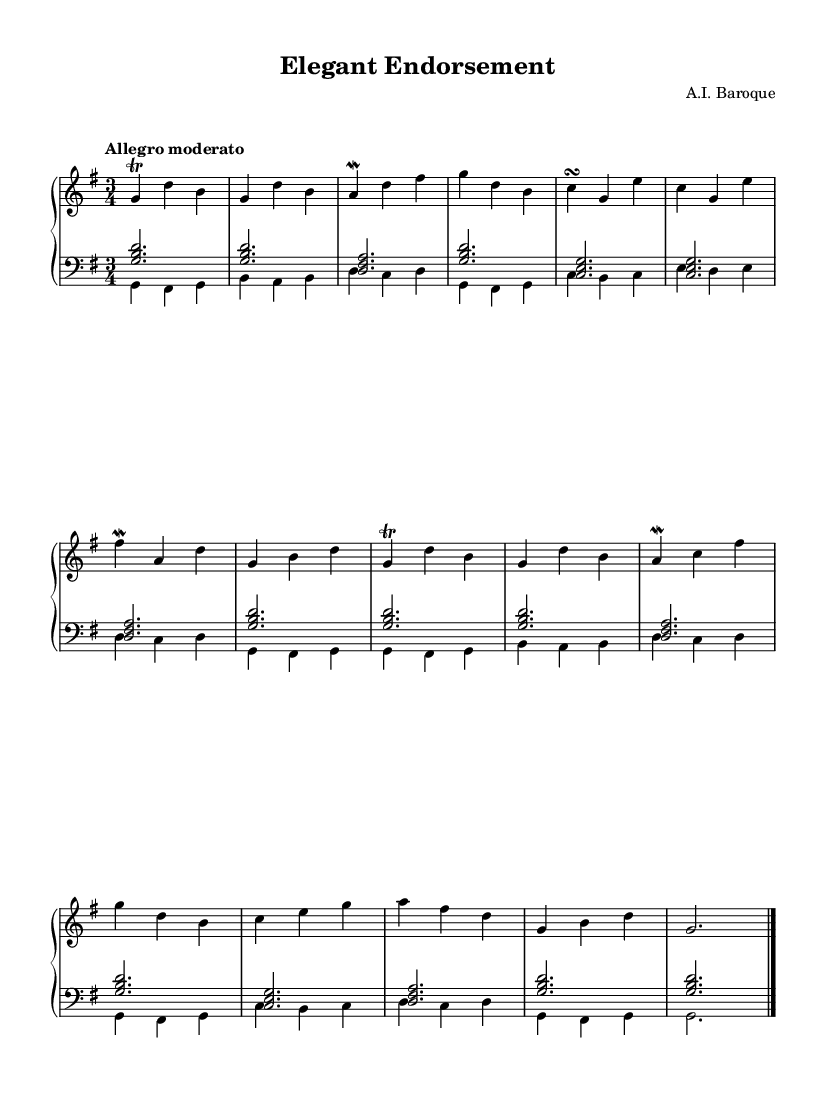What is the key signature of this piece? The key signature is G major, which has one sharp (F#). This can be determined by looking at the key signature indicated at the beginning of the piece.
Answer: G major What is the time signature of this music? The time signature is 3/4, which can be found at the beginning of the sheet music next to the key signature. This indicates that there are three beats in each measure and the quarter note gets one beat.
Answer: 3/4 What is the tempo marking of this piece? The tempo marking indicates "Allegro moderato." This can be found at the start of the piece and denotes a moderately fast tempo.
Answer: Allegro moderato How many measures are in the piece? To find the total number of measures, one must count the number of vertical bar lines throughout the piece. After counting, there are 14 measures.
Answer: 14 What type of ornamentation is used in this music? The piece uses trills and mordents as ornamentation. These are indicated on certain notes by specific symbols. Trills are marked with "tr" and mordents with a zig-zag line.
Answer: Trills and mordents Does this piece follow the typical structure of a Baroque piece? Yes, the piece exhibits the typical structure of a Baroque composition, featuring a clear melodic line with ornamentation and a strong bass line, which is characteristic of the musical style from this period.
Answer: Yes What instruments are typically used to perform pieces like this? This piece is typically performed on the harpsichord, a common instrument in Baroque music, known for its distinctive sound and ability to play rapid passages.
Answer: Harpsichord 